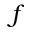<formula> <loc_0><loc_0><loc_500><loc_500>f</formula> 